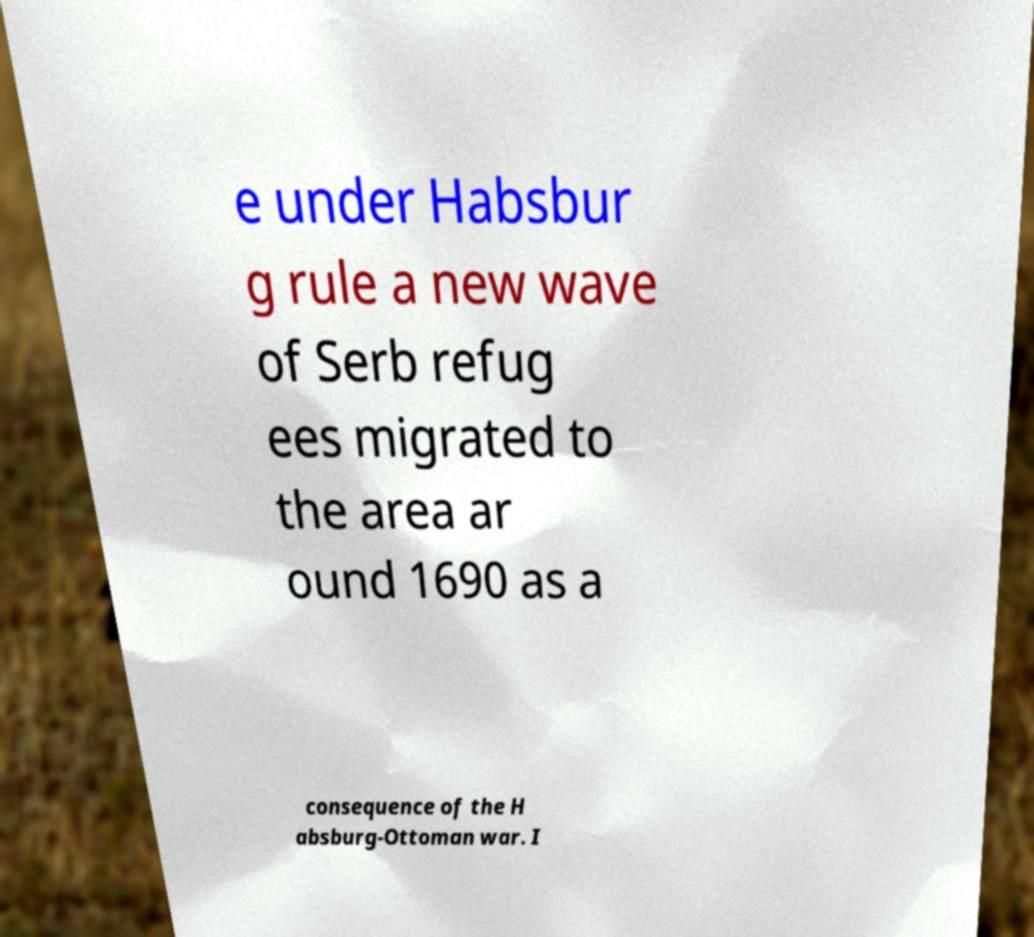What messages or text are displayed in this image? I need them in a readable, typed format. e under Habsbur g rule a new wave of Serb refug ees migrated to the area ar ound 1690 as a consequence of the H absburg-Ottoman war. I 